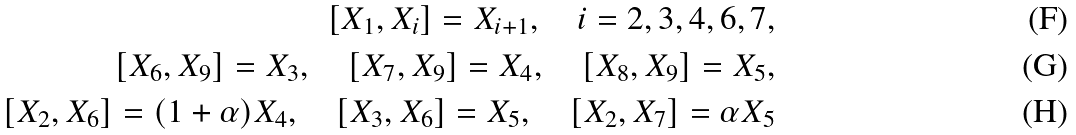<formula> <loc_0><loc_0><loc_500><loc_500>[ X _ { 1 } , X _ { i } ] = X _ { i + 1 } , \quad i = 2 , 3 , 4 , 6 , 7 , \\ [ X _ { 6 } , X _ { 9 } ] = X _ { 3 } , \quad [ X _ { 7 } , X _ { 9 } ] = X _ { 4 } , \quad [ X _ { 8 } , X _ { 9 } ] = X _ { 5 } , \\ [ X _ { 2 } , X _ { 6 } ] = ( 1 + \alpha ) X _ { 4 } , \quad [ X _ { 3 } , X _ { 6 } ] = X _ { 5 } , \quad [ X _ { 2 } , X _ { 7 } ] = \alpha X _ { 5 }</formula> 